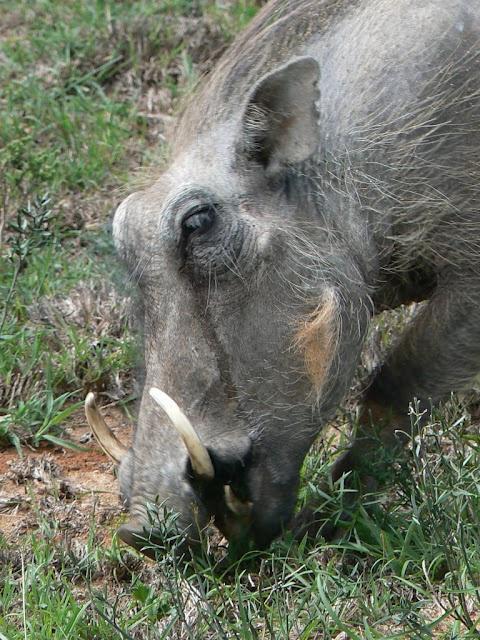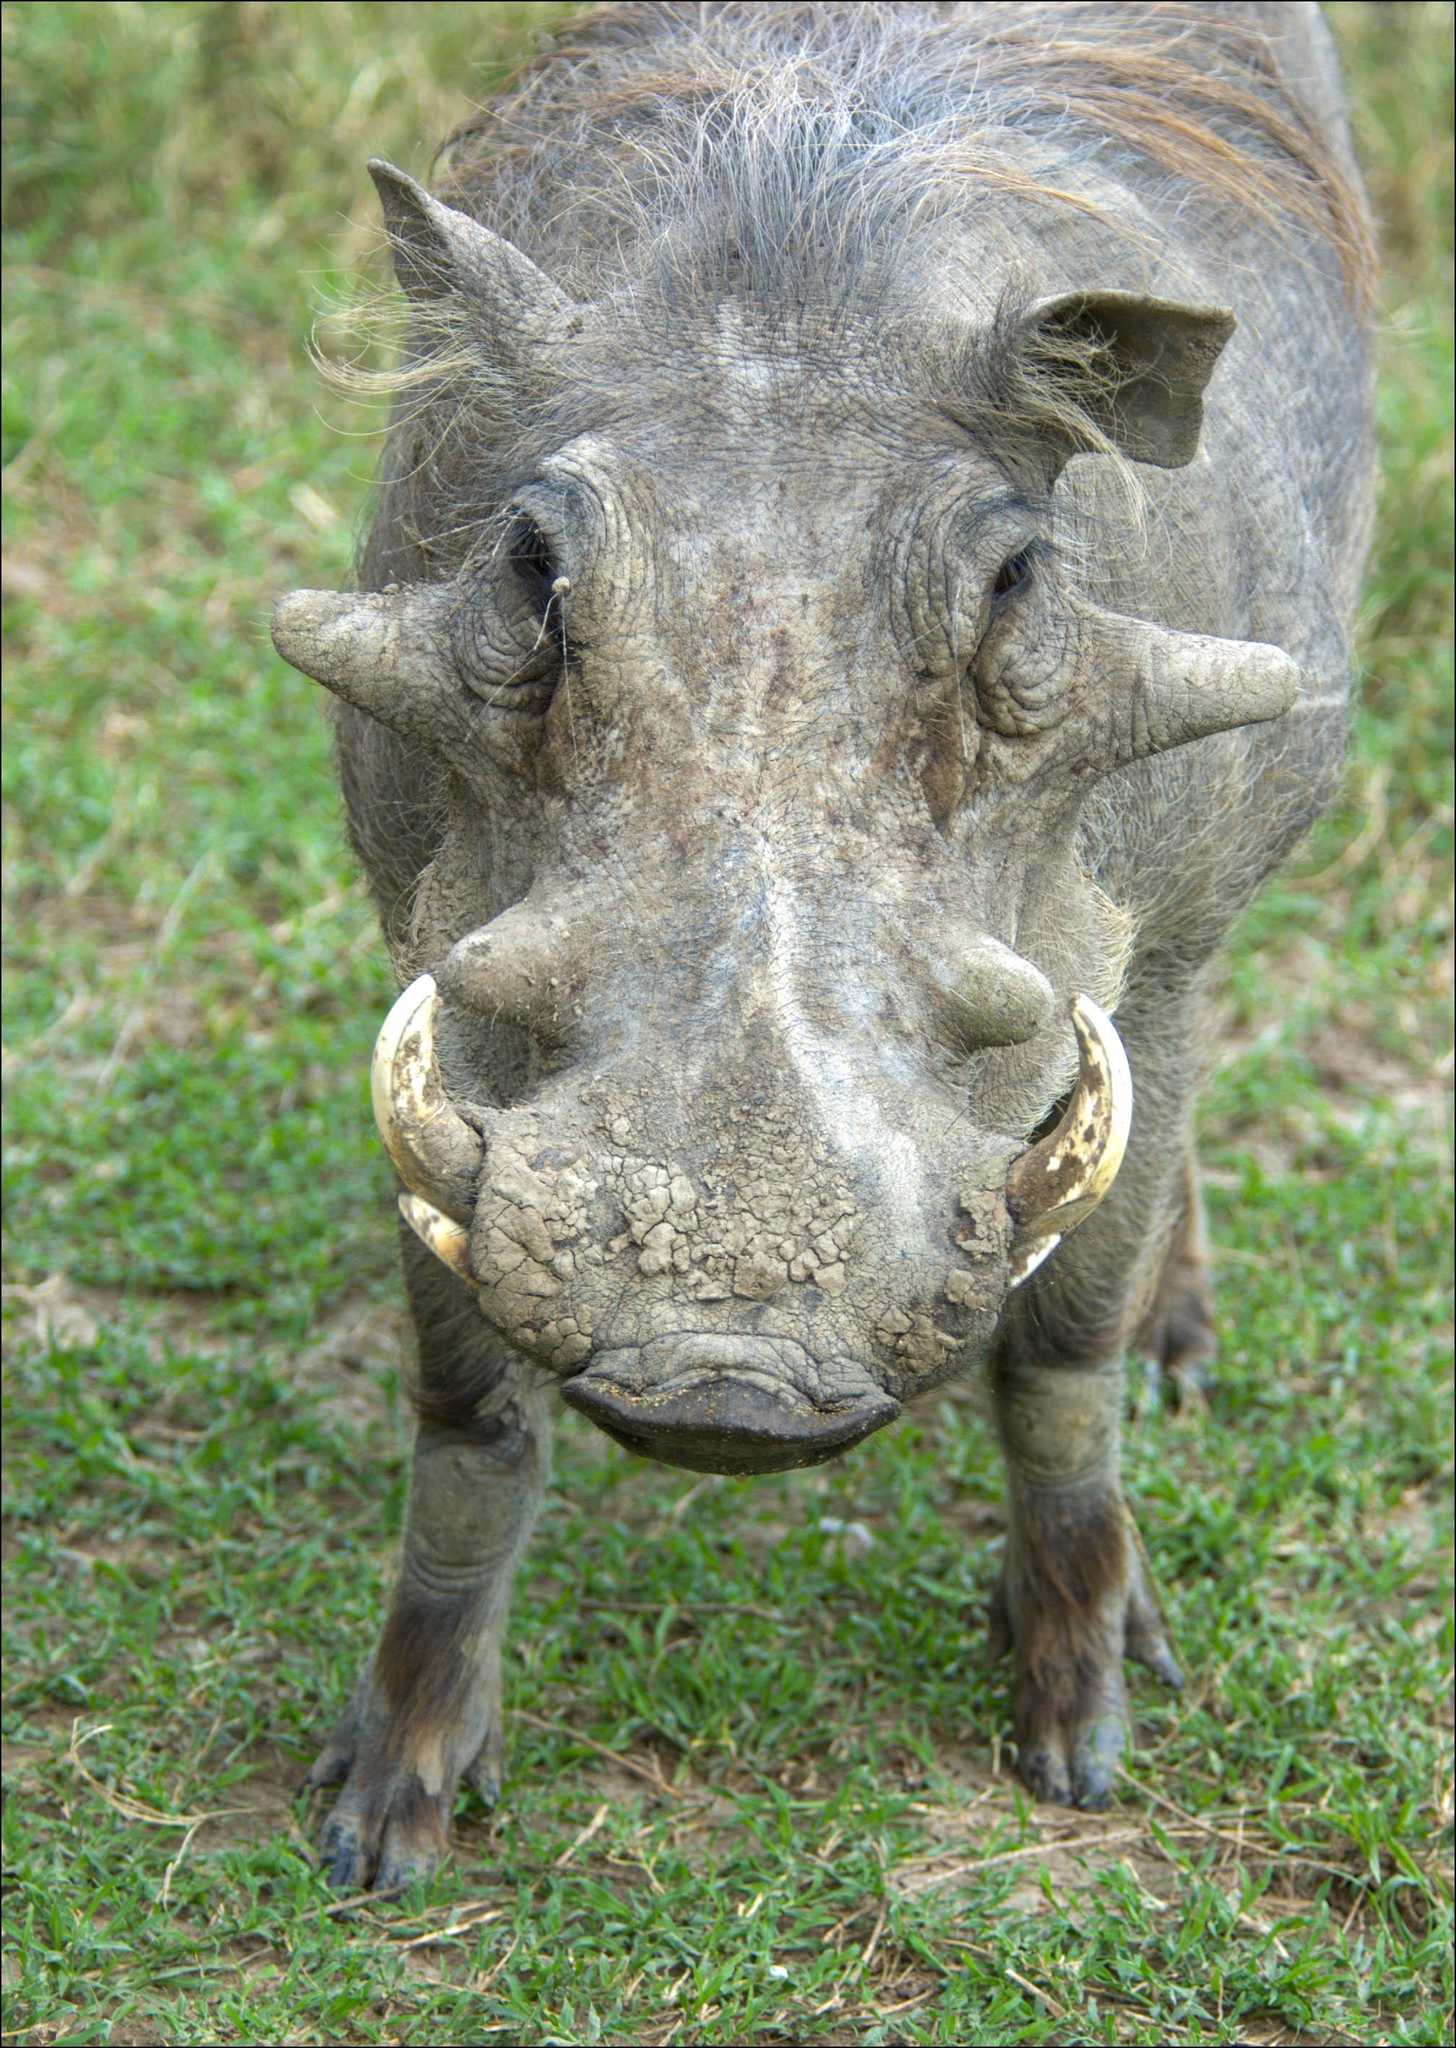The first image is the image on the left, the second image is the image on the right. Examine the images to the left and right. Is the description "The warthog in the image on the left is facing the camera." accurate? Answer yes or no. No. 